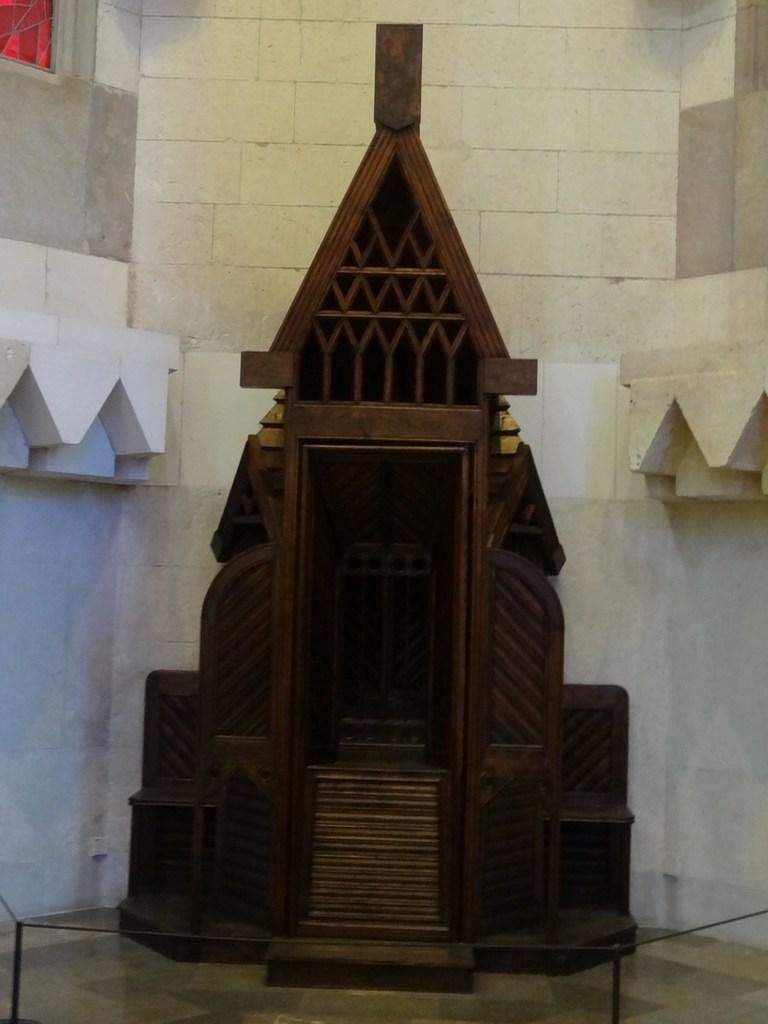What type of structure is visible in the image? There is a building in the image. What is unique about the wooden block in the building? The wooden block is shaped like a church. What is the lowest level of the building? There is a floor at the bottom of the building. Where is the window located on the building? There is a window on the left top of the building. How many eggs are present in the image? There are no eggs visible in the image. What type of hall can be seen in the image? There is no hall present in the image. 